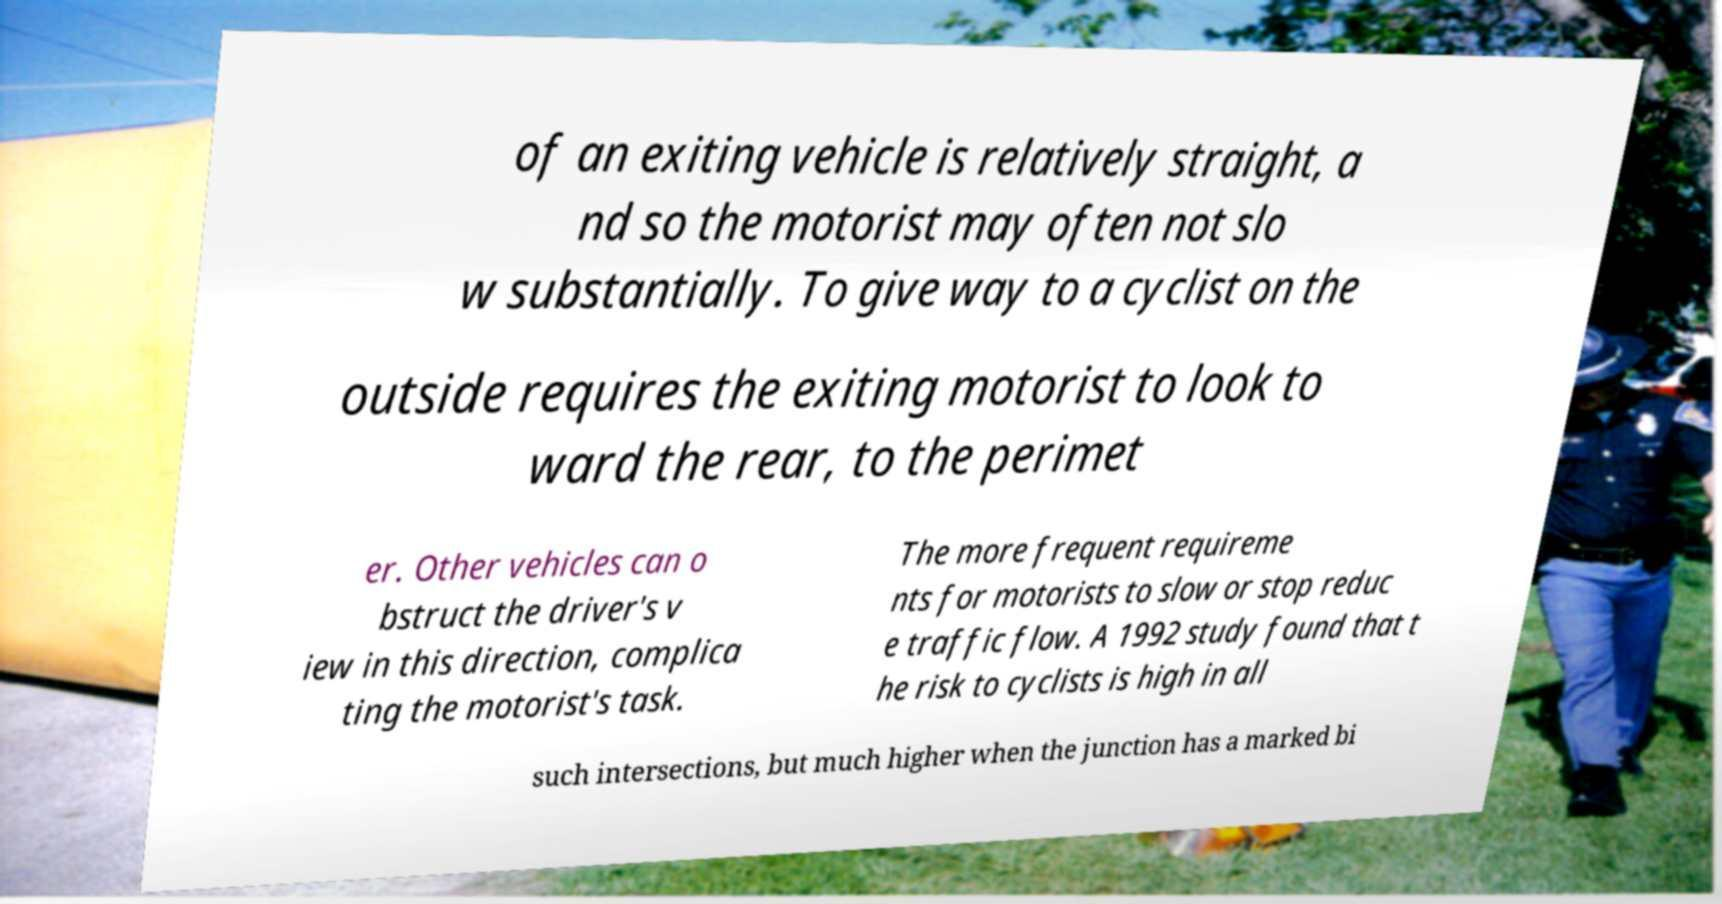Could you extract and type out the text from this image? of an exiting vehicle is relatively straight, a nd so the motorist may often not slo w substantially. To give way to a cyclist on the outside requires the exiting motorist to look to ward the rear, to the perimet er. Other vehicles can o bstruct the driver's v iew in this direction, complica ting the motorist's task. The more frequent requireme nts for motorists to slow or stop reduc e traffic flow. A 1992 study found that t he risk to cyclists is high in all such intersections, but much higher when the junction has a marked bi 